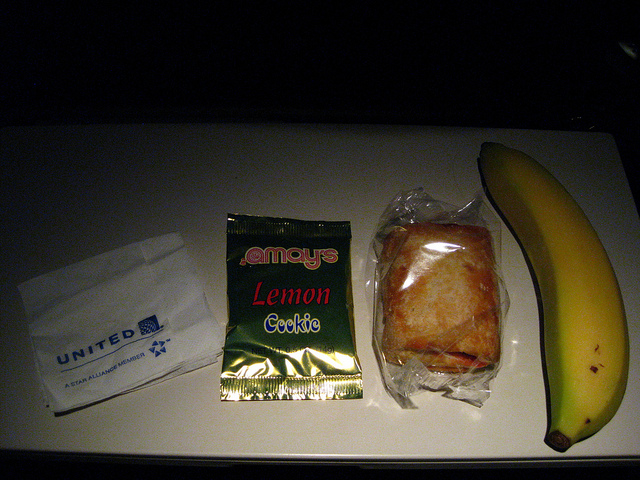Extract all visible text content from this image. UNITED amay's Lemon Cookie ALLIANCE 